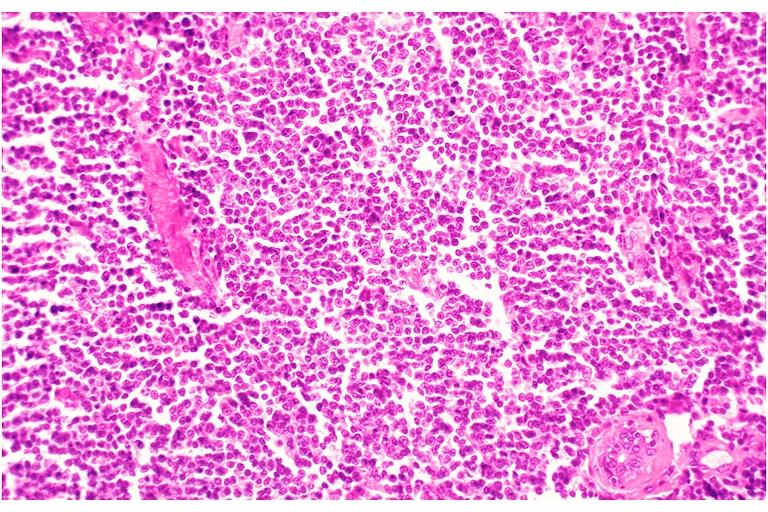what does this image show?
Answer the question using a single word or phrase. Leukemic infiltrate 